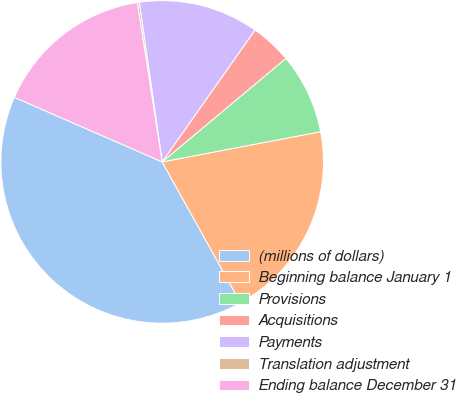Convert chart to OTSL. <chart><loc_0><loc_0><loc_500><loc_500><pie_chart><fcel>(millions of dollars)<fcel>Beginning balance January 1<fcel>Provisions<fcel>Acquisitions<fcel>Payments<fcel>Translation adjustment<fcel>Ending balance December 31<nl><fcel>39.64%<fcel>19.92%<fcel>8.09%<fcel>4.15%<fcel>12.03%<fcel>0.2%<fcel>15.98%<nl></chart> 